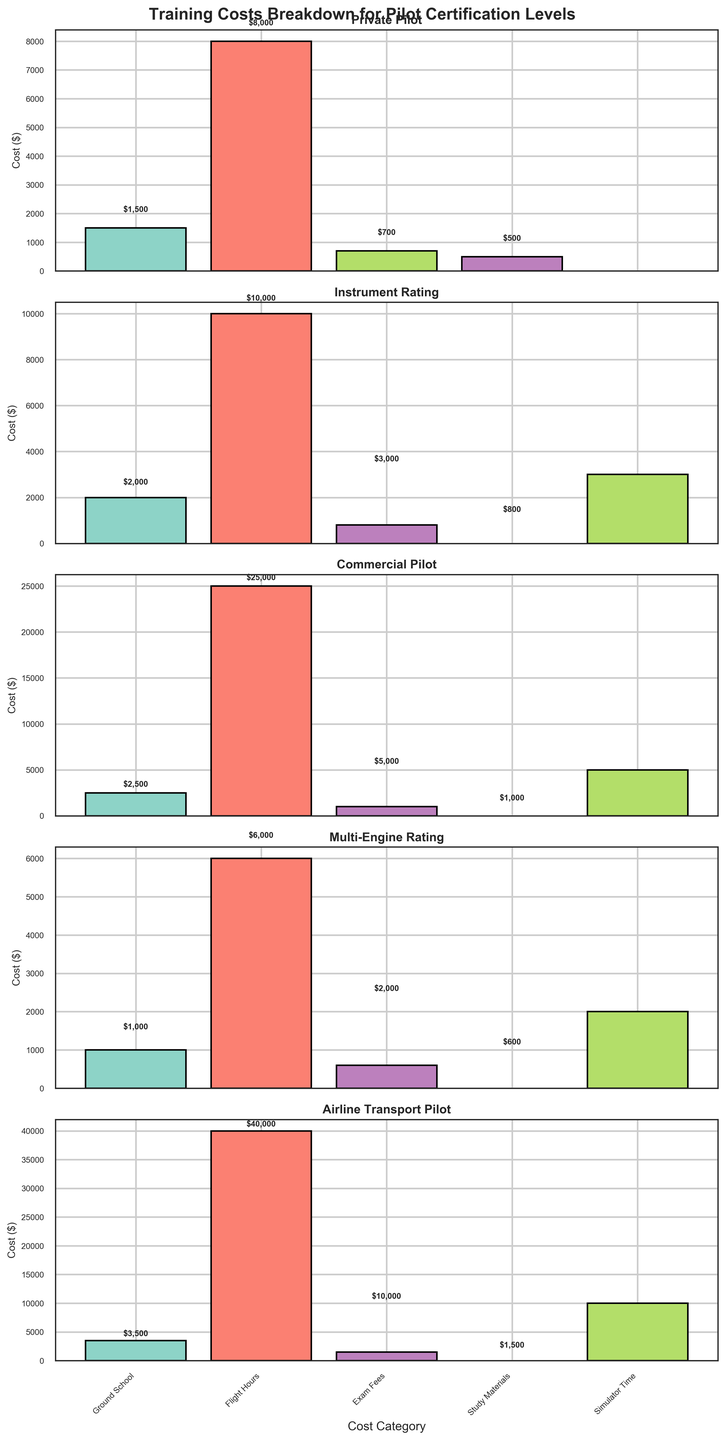What is the highest cost category for Private Pilot certification? The highest cost category for Private Pilot certification can be identified by looking at the tallest bar in the Private Pilot subplot. The tallest bar represents Flight Hours.
Answer: Flight Hours What is the total cost for Instrument Rating certification? The total cost for Instrument Rating certification is the sum of all the bars in the Instrument Rating subplot. Adding Ground School ($2000), Flight Hours ($10000), Simulator Time ($3000), and Exam Fees ($800) gives $2000 + $10000 + $3000 + $800.
Answer: $15,800 Which certification level has the highest overall cost? The highest overall cost can be identified by comparing the total heights of all bars in each subplot. The Airline Transport Pilot certification has the highest costs based on the height sum of its bars, mainly due to the high cost of Flight Hours ($40,000).
Answer: Airline Transport Pilot How does the Simulator Time cost compare between Commercial Pilot and Airline Transport Pilot certifications? To compare Simulator Time costs, observe the bars labeled Simulator Time in both the Commercial Pilot and Airline Transport Pilot subplots. The cost for Commercial Pilot is $5000 and for Airline Transport Pilot is $10000, making the Airline Transport Pilot's Simulator Time twice as expensive.
Answer: Airline Transport Pilot is higher What is the cost difference between the Exam Fees for Private Pilot and Multi-Engine Rating certifications? The cost difference between the Exam Fees for Private Pilot ($700) and Multi-Engine Rating ($600) can be calculated by subtracting $600 from $700.
Answer: $100 Which Cost Category has the largest difference in costs across certification levels? The largest difference can be identified by comparing the ranges of each cost category's bar heights in all subplots. Flight Hours show the largest variation, from $6,000 (Multi-Engine Rating) to $40,000 (Airline Transport Pilot).
Answer: Flight Hours What is the average cost of Ground School across all certification levels? The average cost of Ground School is found by adding the Ground School costs for each certification level and dividing by the number of levels. The costs are $1500 (Private Pilot), $2000 (Instrument Rating), $2500 (Commercial Pilot), $1000 (Multi-Engine Rating), and $3500 (Airline Transport Pilot). The average is ($1500+$2000+$2500+$1000+$3500)/5.
Answer: $2,100 